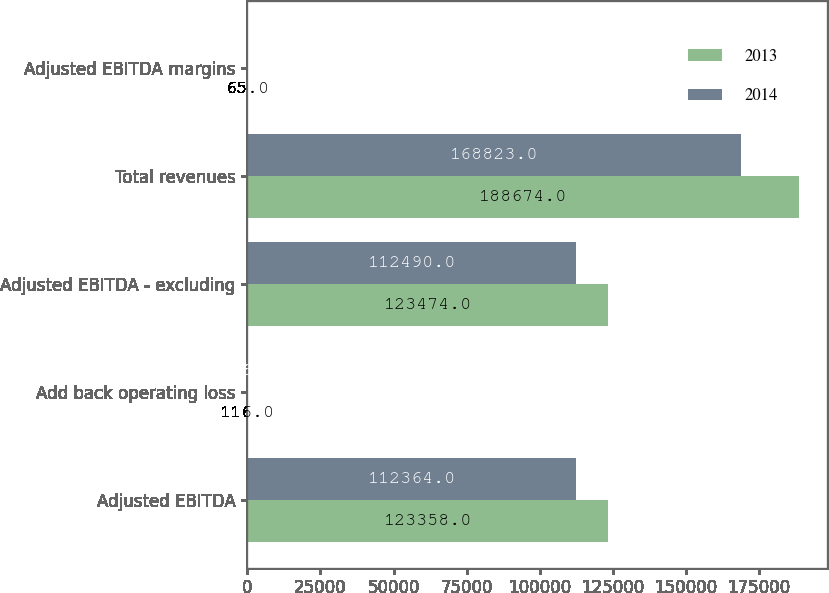Convert chart. <chart><loc_0><loc_0><loc_500><loc_500><stacked_bar_chart><ecel><fcel>Adjusted EBITDA<fcel>Add back operating loss<fcel>Adjusted EBITDA - excluding<fcel>Total revenues<fcel>Adjusted EBITDA margins<nl><fcel>2013<fcel>123358<fcel>116<fcel>123474<fcel>188674<fcel>65<nl><fcel>2014<fcel>112364<fcel>126<fcel>112490<fcel>168823<fcel>67<nl></chart> 